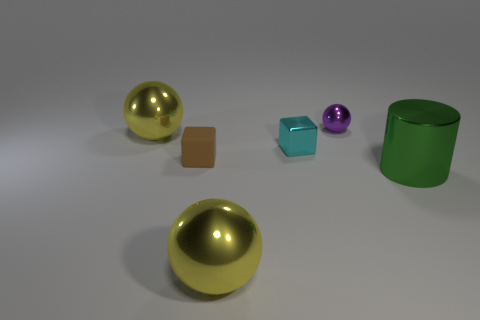Is there any other thing that has the same material as the brown block?
Offer a terse response. No. How many matte objects are purple cylinders or small cyan objects?
Your answer should be very brief. 0. What is the material of the purple sphere?
Provide a succinct answer. Metal. There is a big object right of the thing that is behind the large yellow thing that is behind the tiny cyan thing; what is it made of?
Ensure brevity in your answer.  Metal. What shape is the matte thing that is the same size as the purple metal object?
Offer a very short reply. Cube. What number of things are either small cyan metallic things or balls that are in front of the purple metallic ball?
Give a very brief answer. 3. Does the big yellow thing behind the small cyan object have the same material as the big thing that is to the right of the small ball?
Make the answer very short. Yes. How many cyan things are small metal things or spheres?
Give a very brief answer. 1. The cylinder has what size?
Offer a very short reply. Large. Is the number of tiny metal cubes that are in front of the green thing greater than the number of gray rubber cubes?
Provide a succinct answer. No. 